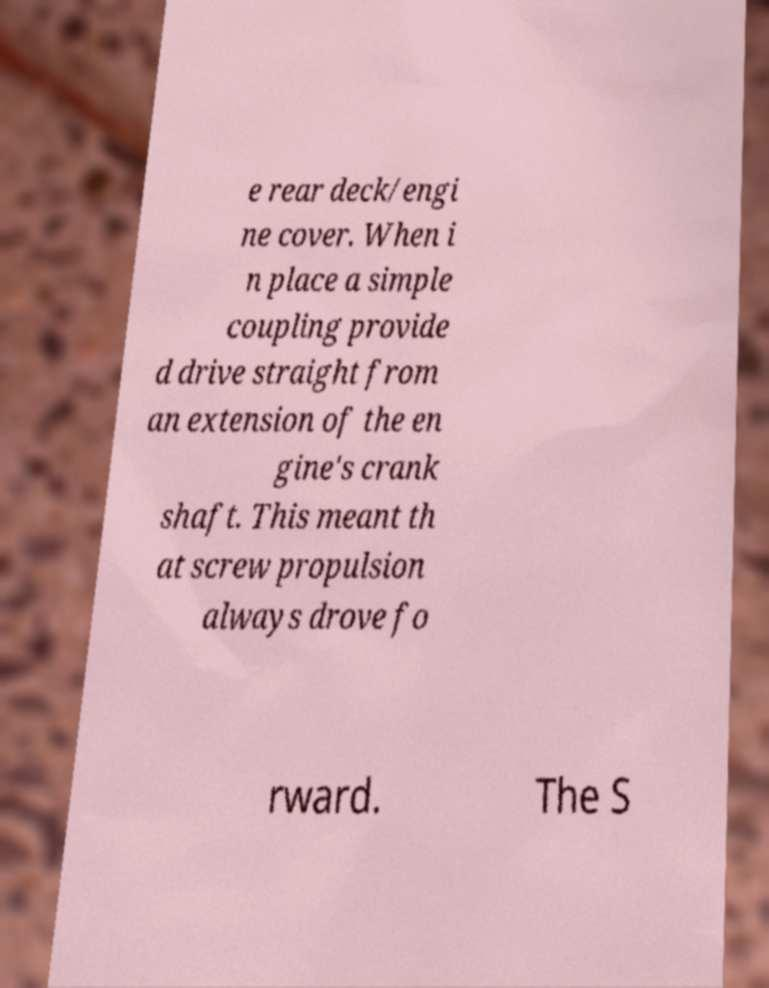Please read and relay the text visible in this image. What does it say? e rear deck/engi ne cover. When i n place a simple coupling provide d drive straight from an extension of the en gine's crank shaft. This meant th at screw propulsion always drove fo rward. The S 